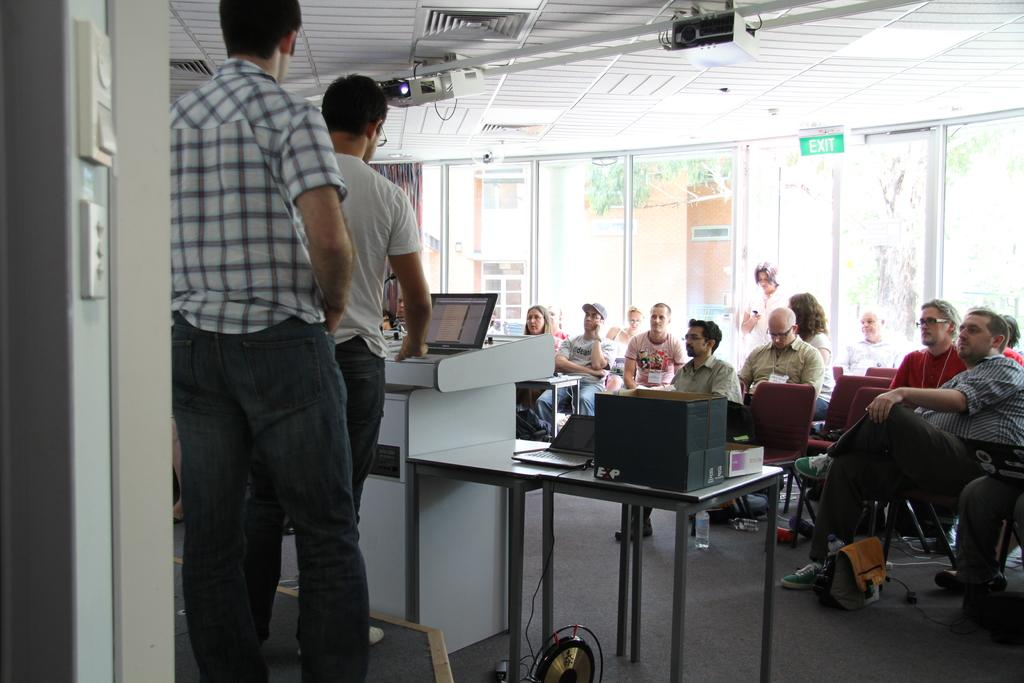How many men are present in the image? There are two men standing in the image. What are the other people doing in the image? Other people are setting up a laptop in the image. What can be seen in the background of the image? There is a glass door, a building, and trees visible in the background of the image. Can you see the men kicking a ball in the image? No, there is no ball or kicking activity present in the image. 